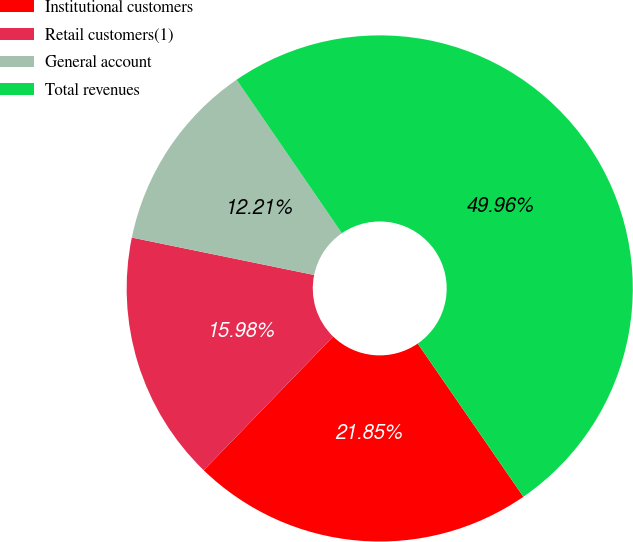<chart> <loc_0><loc_0><loc_500><loc_500><pie_chart><fcel>Institutional customers<fcel>Retail customers(1)<fcel>General account<fcel>Total revenues<nl><fcel>21.85%<fcel>15.98%<fcel>12.21%<fcel>49.96%<nl></chart> 